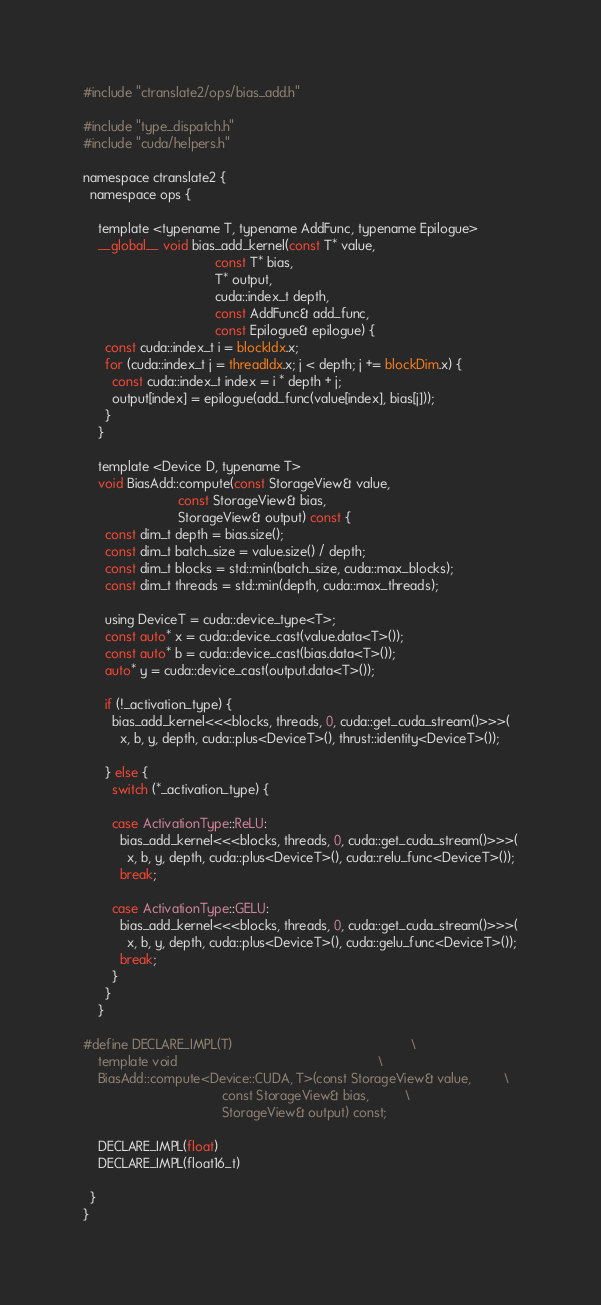Convert code to text. <code><loc_0><loc_0><loc_500><loc_500><_Cuda_>#include "ctranslate2/ops/bias_add.h"

#include "type_dispatch.h"
#include "cuda/helpers.h"

namespace ctranslate2 {
  namespace ops {

    template <typename T, typename AddFunc, typename Epilogue>
    __global__ void bias_add_kernel(const T* value,
                                    const T* bias,
                                    T* output,
                                    cuda::index_t depth,
                                    const AddFunc& add_func,
                                    const Epilogue& epilogue) {
      const cuda::index_t i = blockIdx.x;
      for (cuda::index_t j = threadIdx.x; j < depth; j += blockDim.x) {
        const cuda::index_t index = i * depth + j;
        output[index] = epilogue(add_func(value[index], bias[j]));
      }
    }

    template <Device D, typename T>
    void BiasAdd::compute(const StorageView& value,
                          const StorageView& bias,
                          StorageView& output) const {
      const dim_t depth = bias.size();
      const dim_t batch_size = value.size() / depth;
      const dim_t blocks = std::min(batch_size, cuda::max_blocks);
      const dim_t threads = std::min(depth, cuda::max_threads);

      using DeviceT = cuda::device_type<T>;
      const auto* x = cuda::device_cast(value.data<T>());
      const auto* b = cuda::device_cast(bias.data<T>());
      auto* y = cuda::device_cast(output.data<T>());

      if (!_activation_type) {
        bias_add_kernel<<<blocks, threads, 0, cuda::get_cuda_stream()>>>(
          x, b, y, depth, cuda::plus<DeviceT>(), thrust::identity<DeviceT>());

      } else {
        switch (*_activation_type) {

        case ActivationType::ReLU:
          bias_add_kernel<<<blocks, threads, 0, cuda::get_cuda_stream()>>>(
            x, b, y, depth, cuda::plus<DeviceT>(), cuda::relu_func<DeviceT>());
          break;

        case ActivationType::GELU:
          bias_add_kernel<<<blocks, threads, 0, cuda::get_cuda_stream()>>>(
            x, b, y, depth, cuda::plus<DeviceT>(), cuda::gelu_func<DeviceT>());
          break;
        }
      }
    }

#define DECLARE_IMPL(T)                                                 \
    template void                                                       \
    BiasAdd::compute<Device::CUDA, T>(const StorageView& value,         \
                                      const StorageView& bias,          \
                                      StorageView& output) const;

    DECLARE_IMPL(float)
    DECLARE_IMPL(float16_t)

  }
}
</code> 